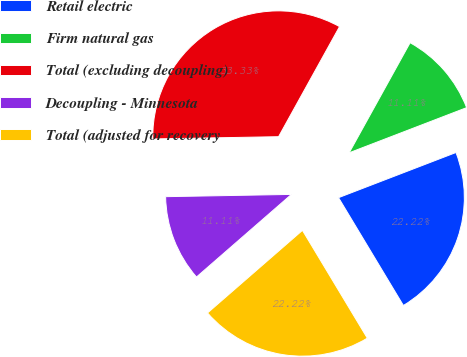Convert chart to OTSL. <chart><loc_0><loc_0><loc_500><loc_500><pie_chart><fcel>Retail electric<fcel>Firm natural gas<fcel>Total (excluding decoupling)<fcel>Decoupling - Minnesota<fcel>Total (adjusted for recovery<nl><fcel>22.22%<fcel>11.11%<fcel>33.33%<fcel>11.11%<fcel>22.22%<nl></chart> 